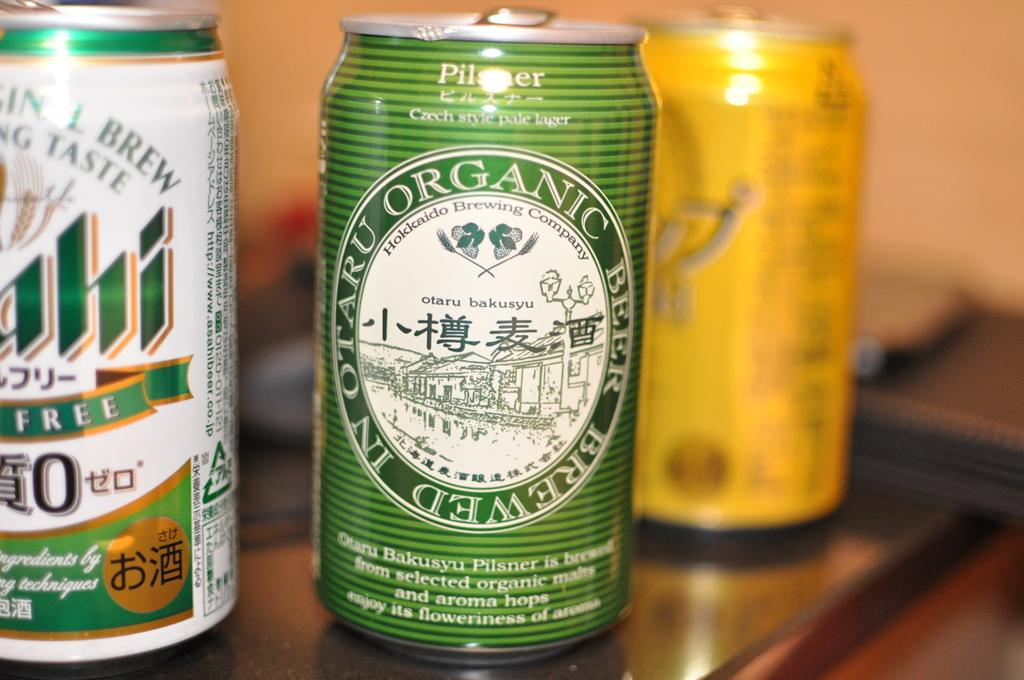<image>
Write a terse but informative summary of the picture. Cans of beer one is made from organic malts and aroma hops. 